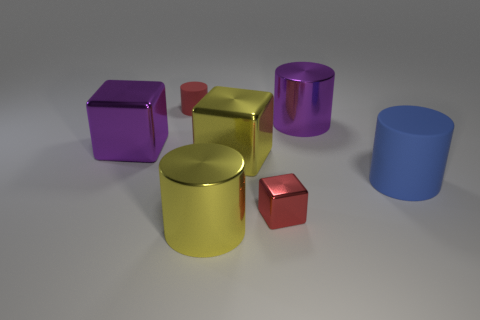What is the material of the other small object that is the same shape as the blue rubber thing?
Provide a succinct answer. Rubber. Do the large block that is on the right side of the yellow metal cylinder and the small red object to the right of the large yellow metal cylinder have the same material?
Keep it short and to the point. Yes. How many small gray matte cylinders are there?
Provide a short and direct response. 0. How many tiny red rubber things are the same shape as the tiny red metallic thing?
Keep it short and to the point. 0. Is the small rubber thing the same shape as the blue rubber object?
Your response must be concise. Yes. The yellow block is what size?
Your answer should be very brief. Large. What number of red cylinders have the same size as the yellow shiny block?
Your response must be concise. 0. Does the cylinder behind the purple metal cylinder have the same size as the yellow shiny thing that is on the left side of the large yellow cube?
Give a very brief answer. No. There is a small red object right of the tiny red matte object; what is its shape?
Your response must be concise. Cube. What is the material of the yellow thing in front of the rubber cylinder to the right of the red shiny block?
Provide a short and direct response. Metal. 